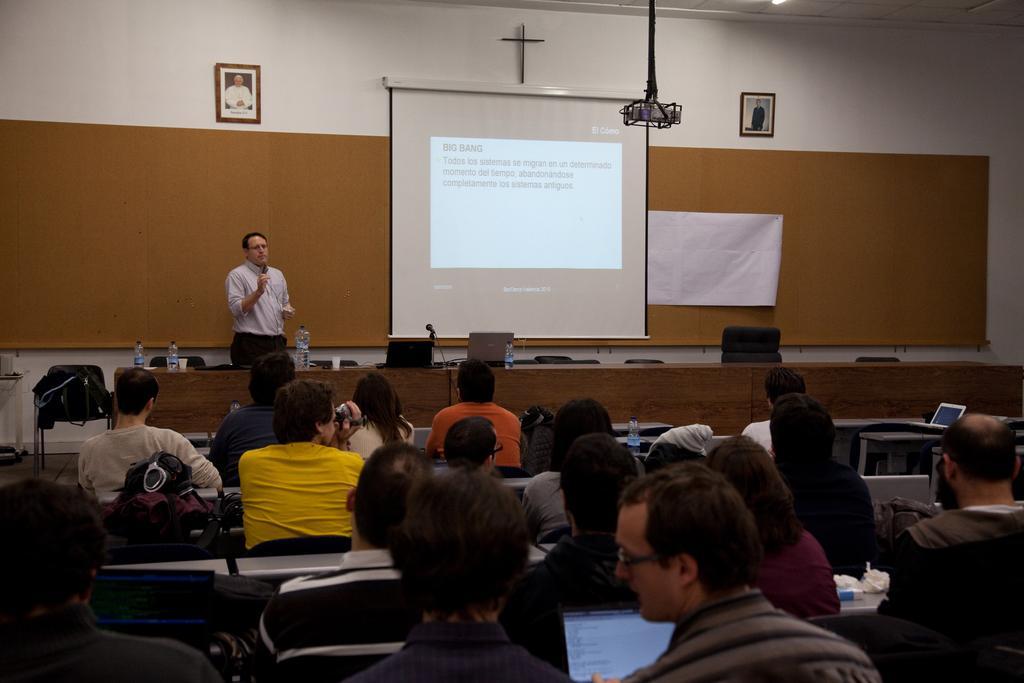In one or two sentences, can you explain what this image depicts? In this image there are groups of persons sitting, there is a person standing and holding an object, there are objects on the desk, there are chairs, there is a projector, there is a screen, there are photo frames on the wall, towards the left of the image there is an object truncated, there is a chart on the wall. 